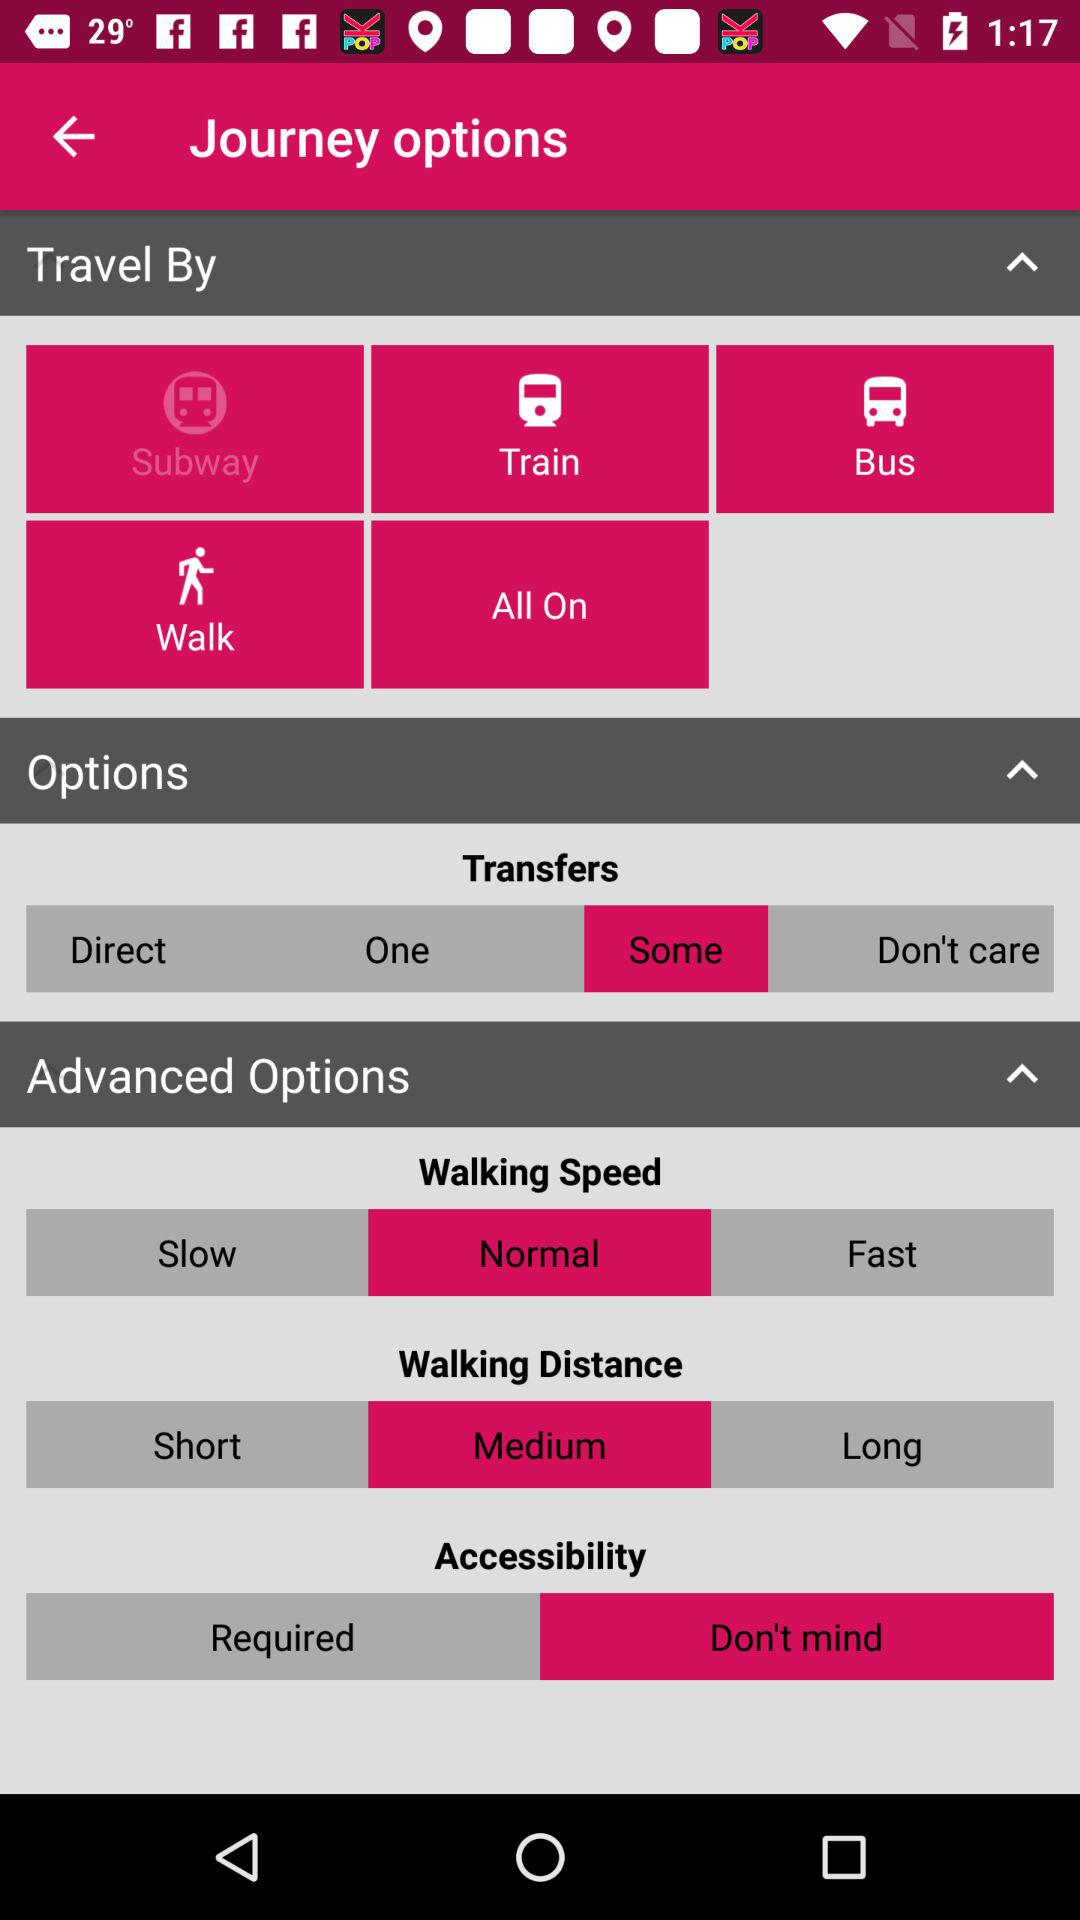How many travel options are available?
Answer the question using a single word or phrase. 5 